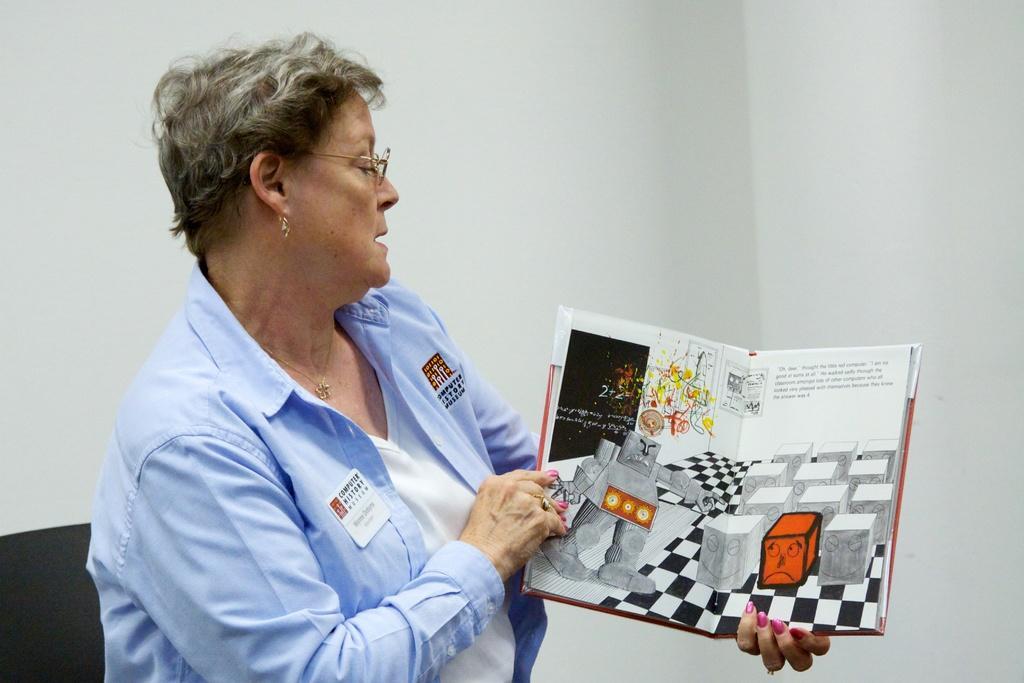Please provide a concise description of this image. In this image there is one woman who is holding a book, and in the book there is text and some images and in the background there is wall. 